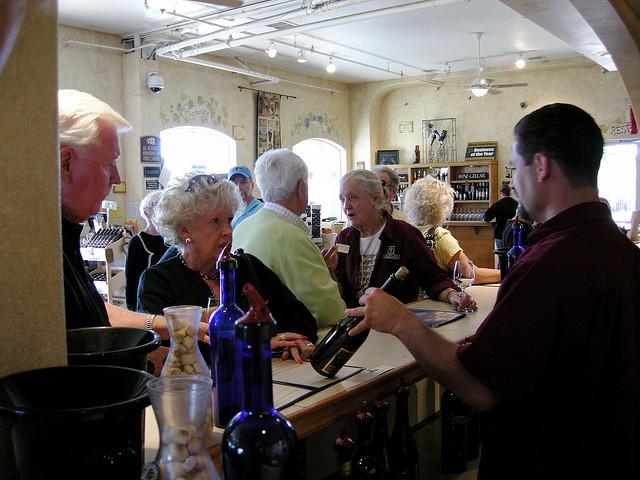What are people waiting for?
Be succinct. Drink. Are these people at a bar or a house?
Short answer required. Bar. What is the man holding?
Quick response, please. Wine bottle. What is the person behind the counter serving?
Answer briefly. Wine. 